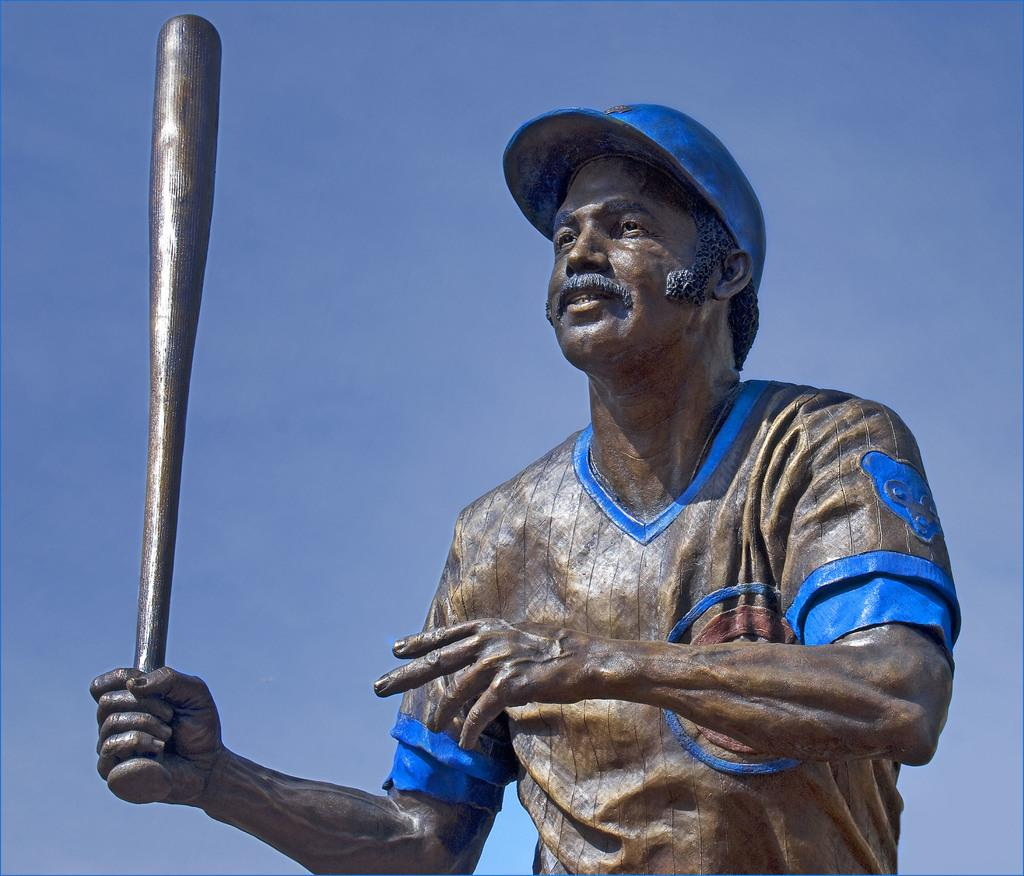What is the main subject of the image? A: The main subject of the image is a statue. What is the statue depicting? The statue is of a person. What object is the person in the statue holding? The person is holding a baseball bat. What type of waste can be seen in the image? There is no waste present in the image; it features a statue of a person holding a baseball bat. How does the statue represent society in the image? The statue does not represent society in the image; it is a depiction of a person holding a baseball bat. 